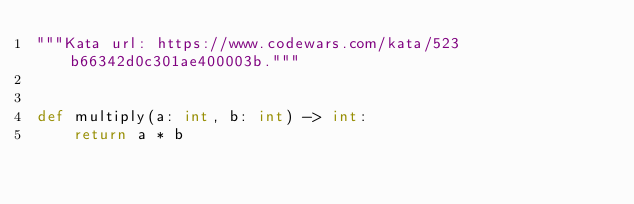<code> <loc_0><loc_0><loc_500><loc_500><_Python_>"""Kata url: https://www.codewars.com/kata/523b66342d0c301ae400003b."""


def multiply(a: int, b: int) -> int:
    return a * b
</code> 